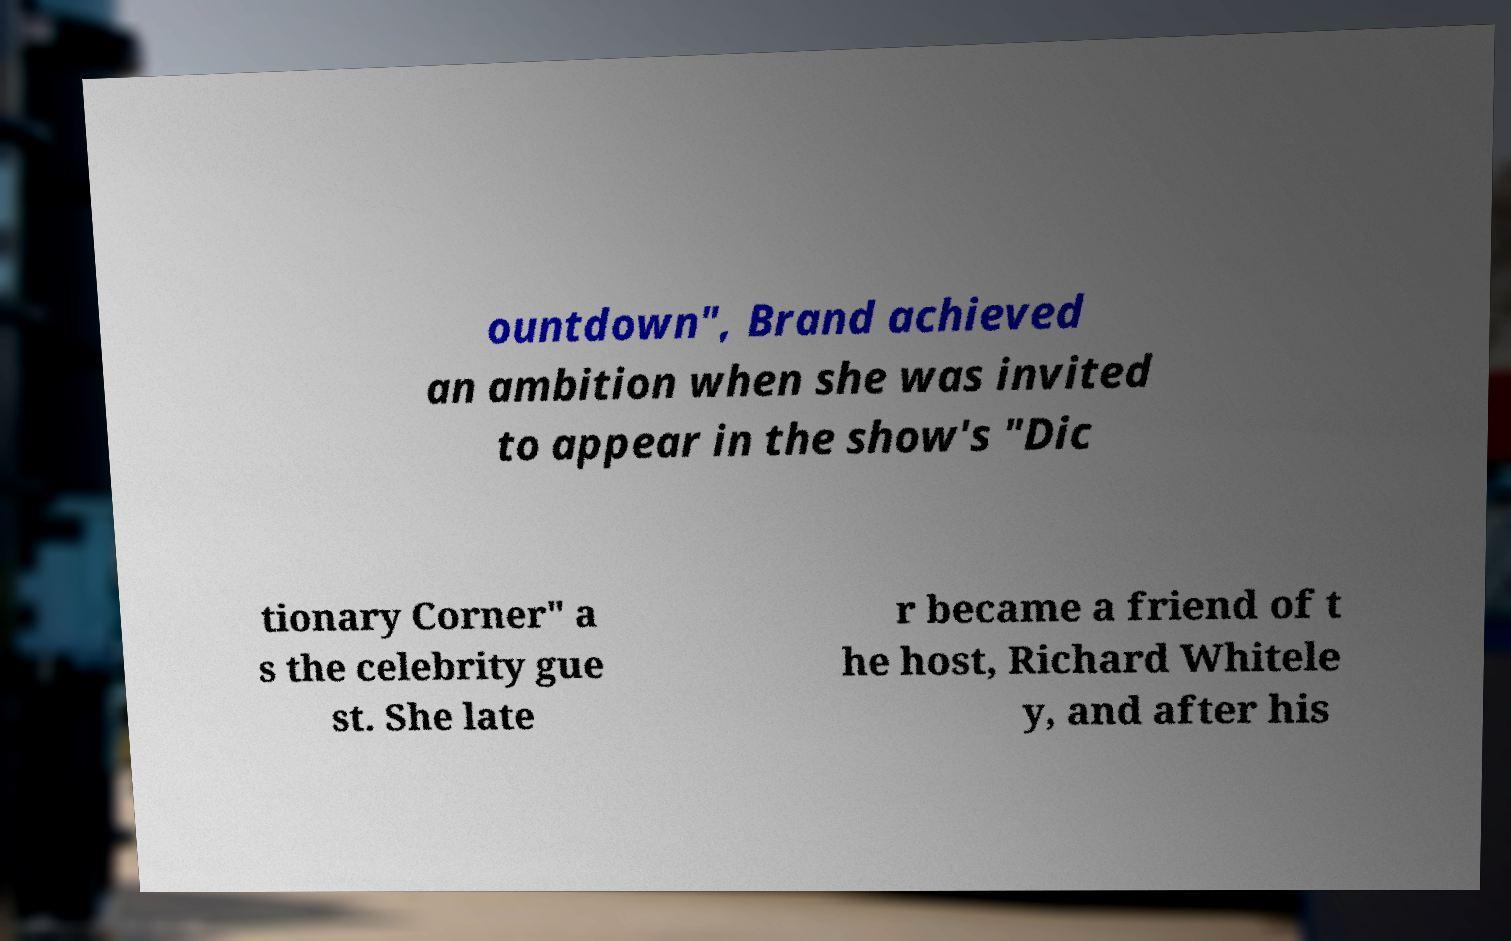Please read and relay the text visible in this image. What does it say? ountdown", Brand achieved an ambition when she was invited to appear in the show's "Dic tionary Corner" a s the celebrity gue st. She late r became a friend of t he host, Richard Whitele y, and after his 